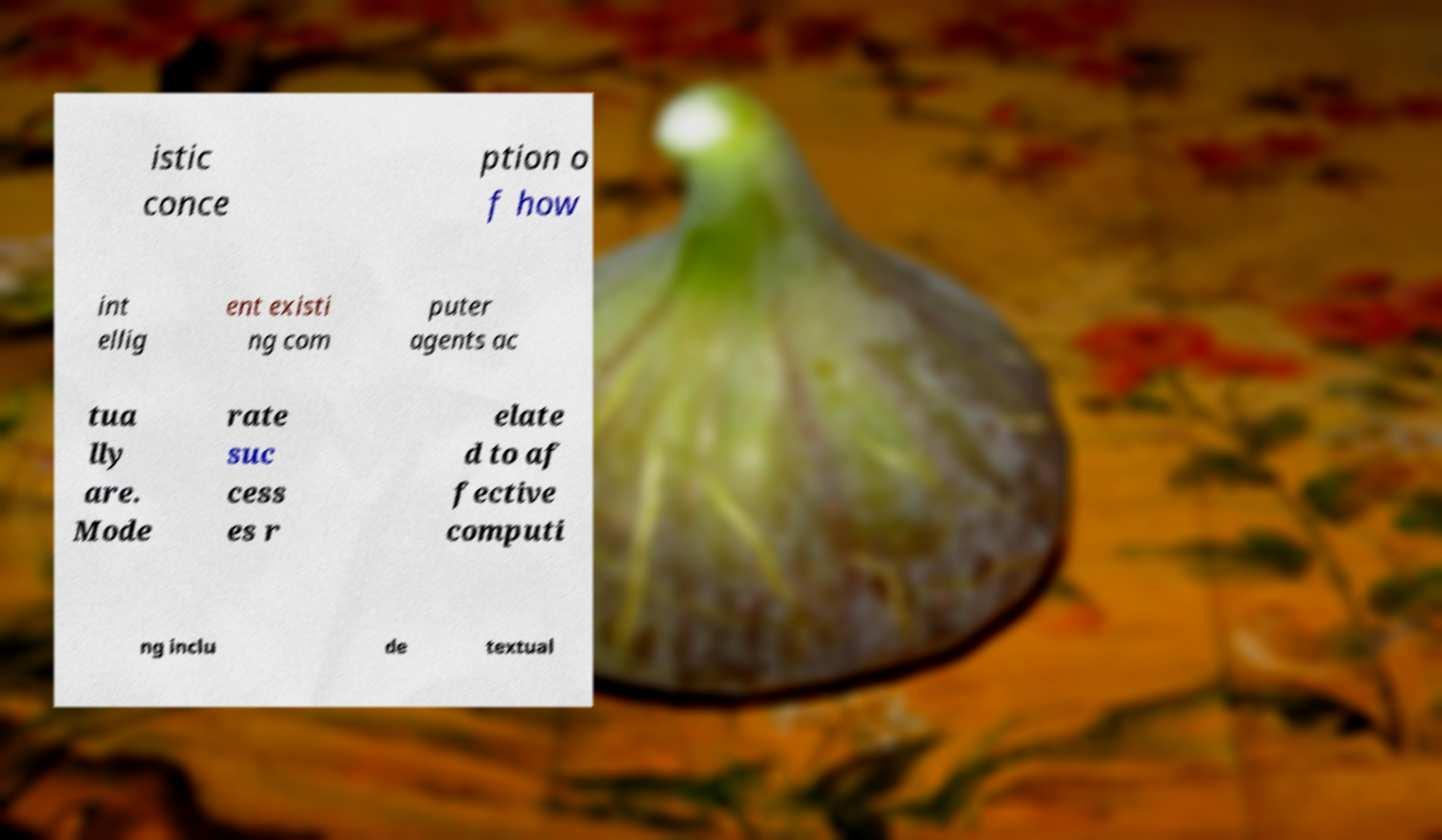I need the written content from this picture converted into text. Can you do that? istic conce ption o f how int ellig ent existi ng com puter agents ac tua lly are. Mode rate suc cess es r elate d to af fective computi ng inclu de textual 